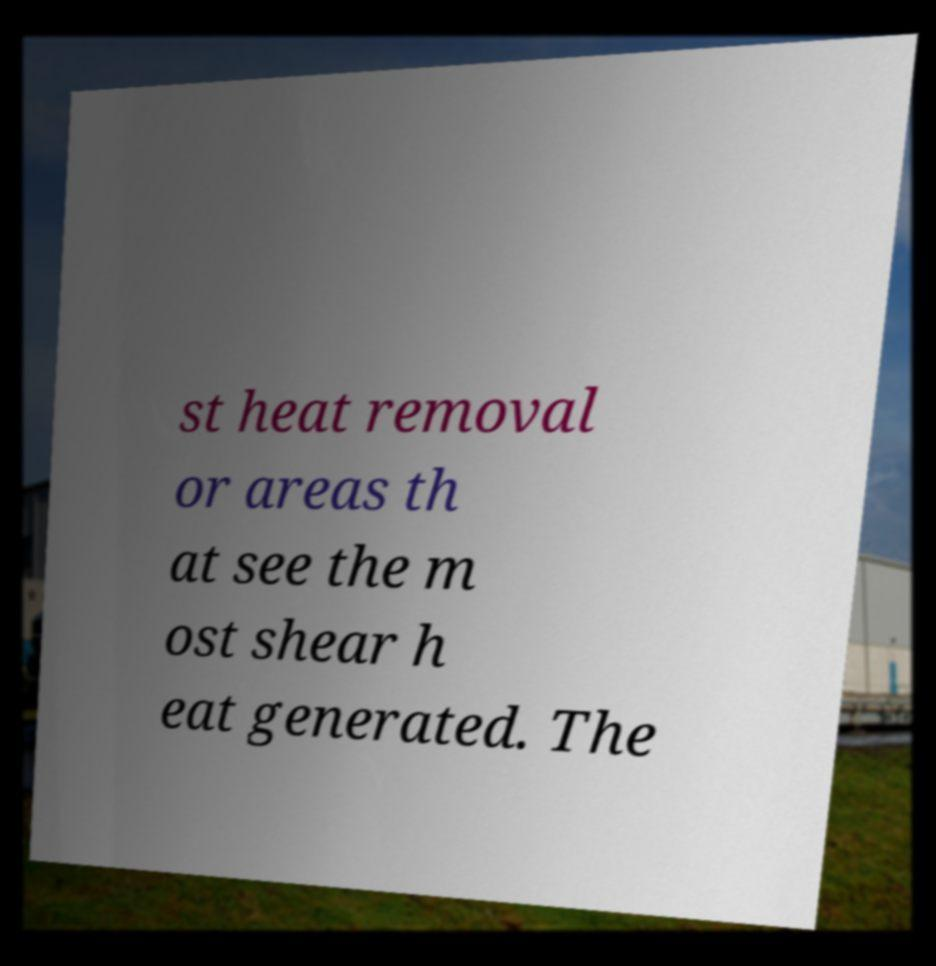Please identify and transcribe the text found in this image. st heat removal or areas th at see the m ost shear h eat generated. The 